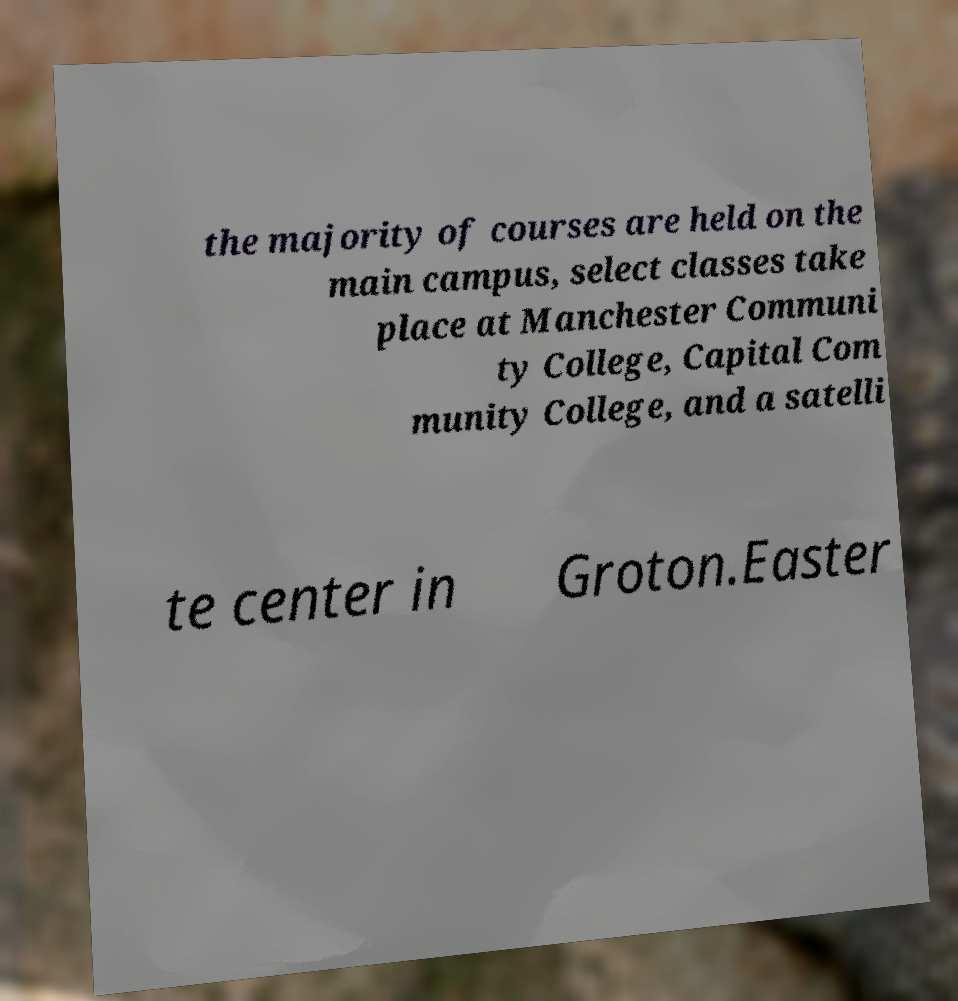Can you read and provide the text displayed in the image?This photo seems to have some interesting text. Can you extract and type it out for me? the majority of courses are held on the main campus, select classes take place at Manchester Communi ty College, Capital Com munity College, and a satelli te center in Groton.Easter 